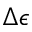Convert formula to latex. <formula><loc_0><loc_0><loc_500><loc_500>\Delta \epsilon</formula> 